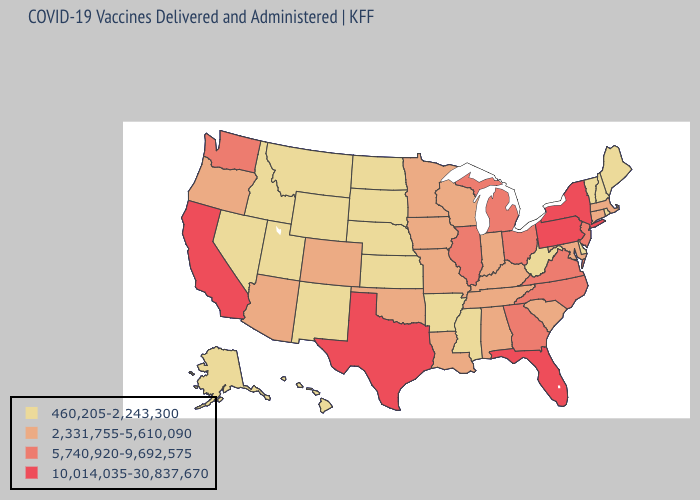Does Louisiana have the lowest value in the South?
Short answer required. No. Among the states that border North Carolina , which have the highest value?
Answer briefly. Georgia, Virginia. Which states have the lowest value in the USA?
Write a very short answer. Alaska, Arkansas, Delaware, Hawaii, Idaho, Kansas, Maine, Mississippi, Montana, Nebraska, Nevada, New Hampshire, New Mexico, North Dakota, Rhode Island, South Dakota, Utah, Vermont, West Virginia, Wyoming. Does Alaska have the same value as Rhode Island?
Write a very short answer. Yes. What is the value of Oklahoma?
Write a very short answer. 2,331,755-5,610,090. Which states have the highest value in the USA?
Be succinct. California, Florida, New York, Pennsylvania, Texas. Name the states that have a value in the range 10,014,035-30,837,670?
Concise answer only. California, Florida, New York, Pennsylvania, Texas. What is the highest value in the West ?
Be succinct. 10,014,035-30,837,670. What is the value of California?
Keep it brief. 10,014,035-30,837,670. Name the states that have a value in the range 10,014,035-30,837,670?
Give a very brief answer. California, Florida, New York, Pennsylvania, Texas. Which states have the lowest value in the South?
Give a very brief answer. Arkansas, Delaware, Mississippi, West Virginia. Which states have the lowest value in the USA?
Short answer required. Alaska, Arkansas, Delaware, Hawaii, Idaho, Kansas, Maine, Mississippi, Montana, Nebraska, Nevada, New Hampshire, New Mexico, North Dakota, Rhode Island, South Dakota, Utah, Vermont, West Virginia, Wyoming. What is the value of Wisconsin?
Quick response, please. 2,331,755-5,610,090. Does the first symbol in the legend represent the smallest category?
Short answer required. Yes. What is the value of South Dakota?
Keep it brief. 460,205-2,243,300. 